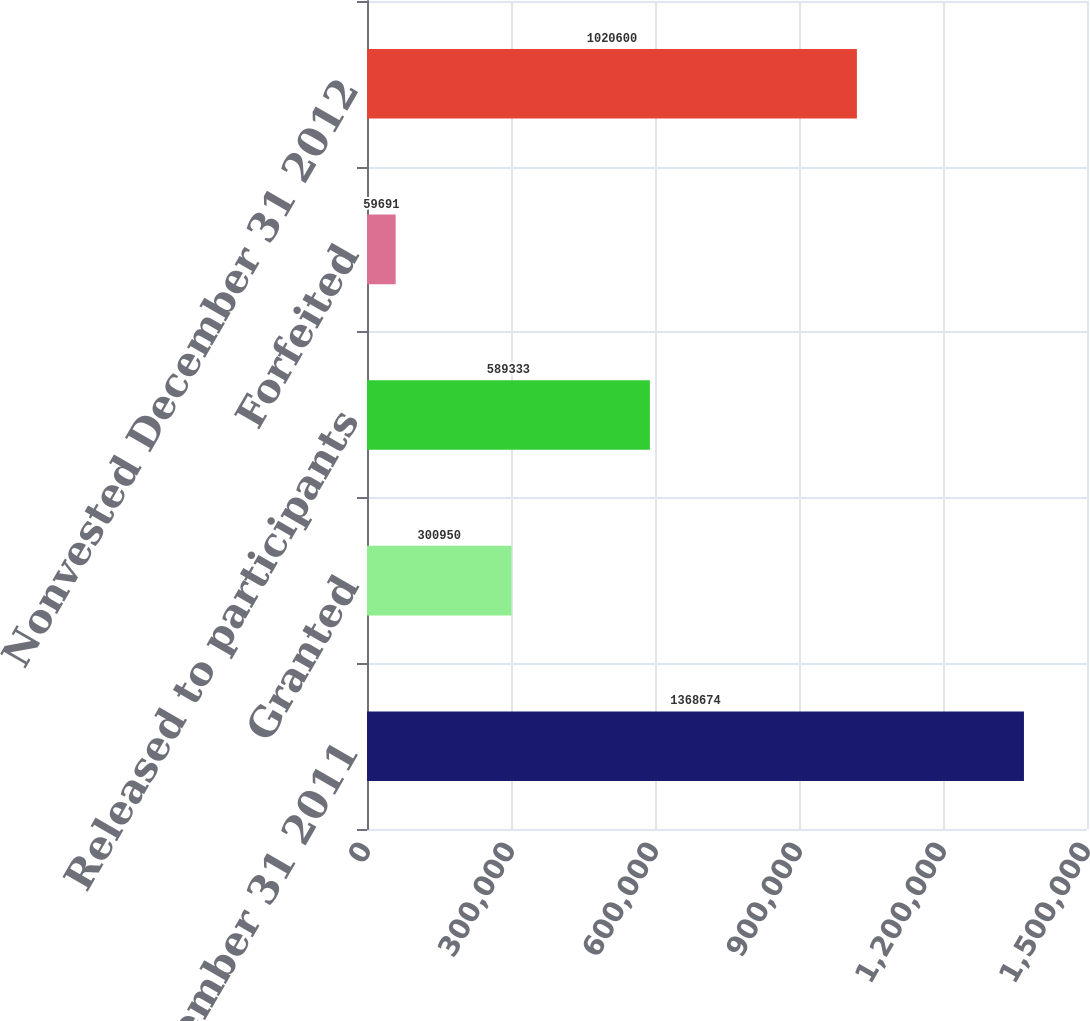Convert chart to OTSL. <chart><loc_0><loc_0><loc_500><loc_500><bar_chart><fcel>Nonvested December 31 2011<fcel>Granted<fcel>Released to participants<fcel>Forfeited<fcel>Nonvested December 31 2012<nl><fcel>1.36867e+06<fcel>300950<fcel>589333<fcel>59691<fcel>1.0206e+06<nl></chart> 